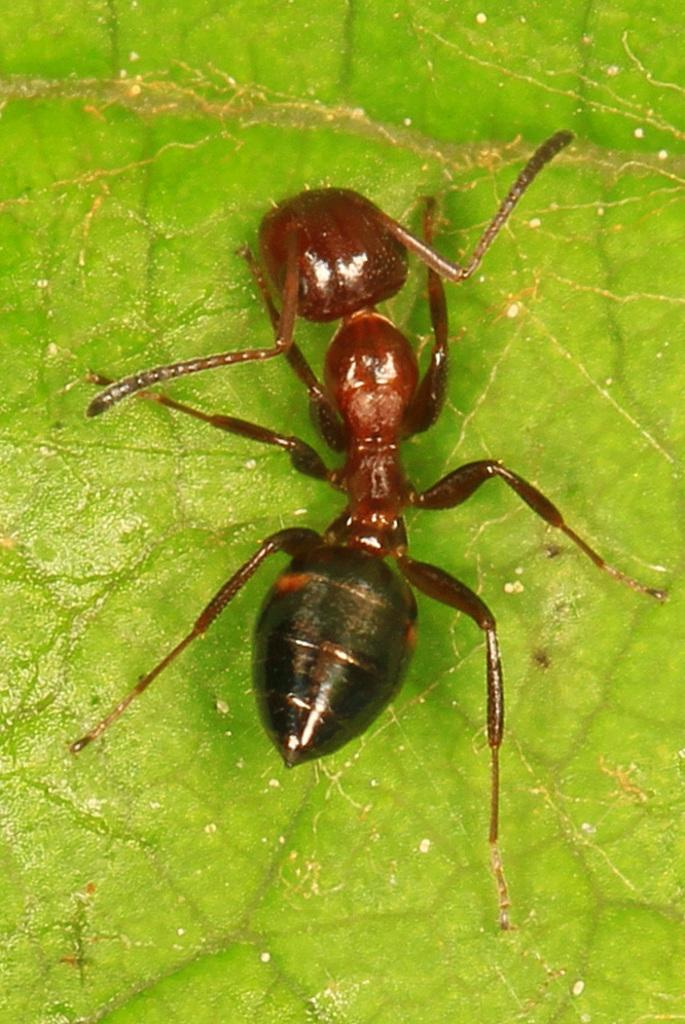What is the main subject of the image? The main subject of the image is an ant. Where is the ant located in the image? The ant is on a leaf. What type of lift can be seen in the image? There is no lift present in the image; it features an ant on a leaf. What part of the ant's body is responsible for its nervous system in the image? There is no information about the ant's nervous system in the image, as it only shows the ant on a leaf. 